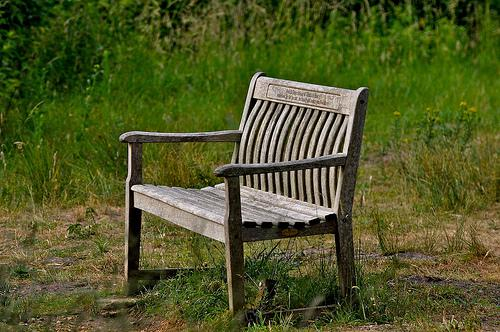Question: what is written on the bench?
Choices:
A. A name.
B. A poem.
C. The name of the manufacturer.
D. An inscription.
Answer with the letter. Answer: D Question: when was this taken?
Choices:
A. At night.
B. At sunrise.
C. At dusk.
D. During the day.
Answer with the letter. Answer: D Question: where was this taken?
Choices:
A. In a house.
B. At a mall.
C. In a park.
D. On a city street.
Answer with the letter. Answer: C 